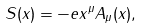Convert formula to latex. <formula><loc_0><loc_0><loc_500><loc_500>S ( x ) = - e x ^ { \mu } A _ { \mu } ( x ) ,</formula> 